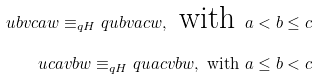Convert formula to latex. <formula><loc_0><loc_0><loc_500><loc_500>u b v c a w \equiv _ { q H } q u b v a c w , \text { with } a < b \leq c \\ u c a v b w \equiv _ { q H } q u a c v b w , \text { with } a \leq b < c</formula> 